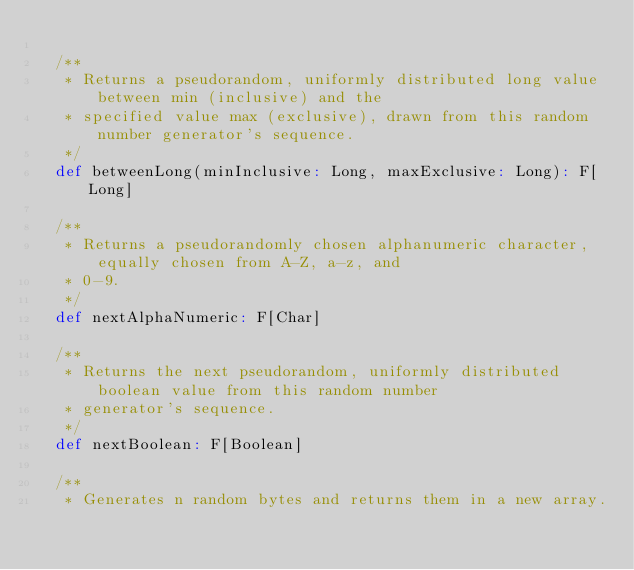<code> <loc_0><loc_0><loc_500><loc_500><_Scala_>
  /**
   * Returns a pseudorandom, uniformly distributed long value between min (inclusive) and the
   * specified value max (exclusive), drawn from this random number generator's sequence.
   */
  def betweenLong(minInclusive: Long, maxExclusive: Long): F[Long]

  /**
   * Returns a pseudorandomly chosen alphanumeric character, equally chosen from A-Z, a-z, and
   * 0-9.
   */
  def nextAlphaNumeric: F[Char]

  /**
   * Returns the next pseudorandom, uniformly distributed boolean value from this random number
   * generator's sequence.
   */
  def nextBoolean: F[Boolean]

  /**
   * Generates n random bytes and returns them in a new array.</code> 